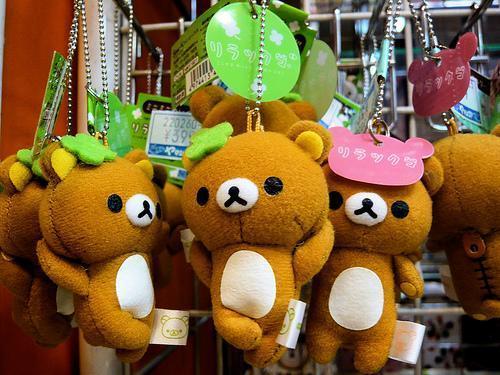How many pink tags are there?
Give a very brief answer. 1. 